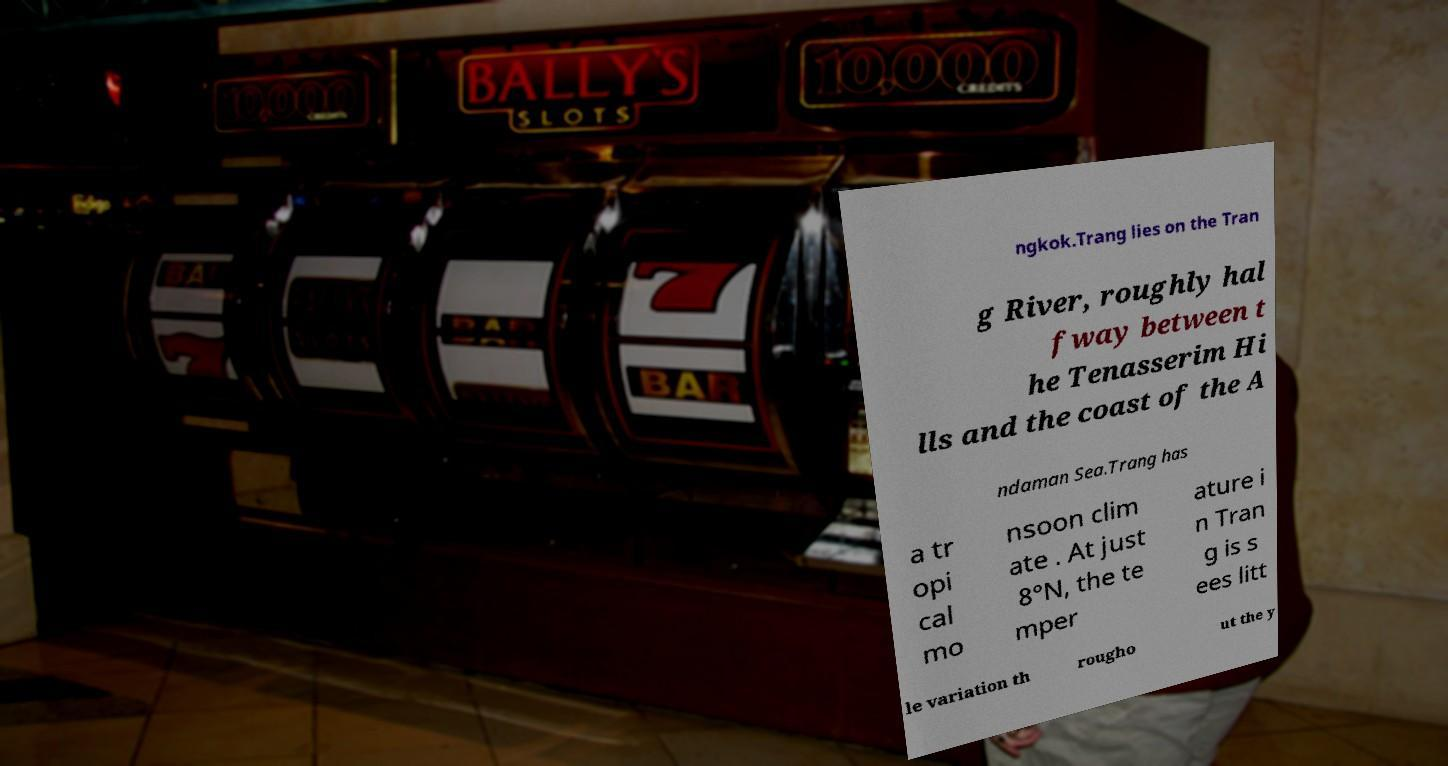For documentation purposes, I need the text within this image transcribed. Could you provide that? ngkok.Trang lies on the Tran g River, roughly hal fway between t he Tenasserim Hi lls and the coast of the A ndaman Sea.Trang has a tr opi cal mo nsoon clim ate . At just 8°N, the te mper ature i n Tran g is s ees litt le variation th rougho ut the y 